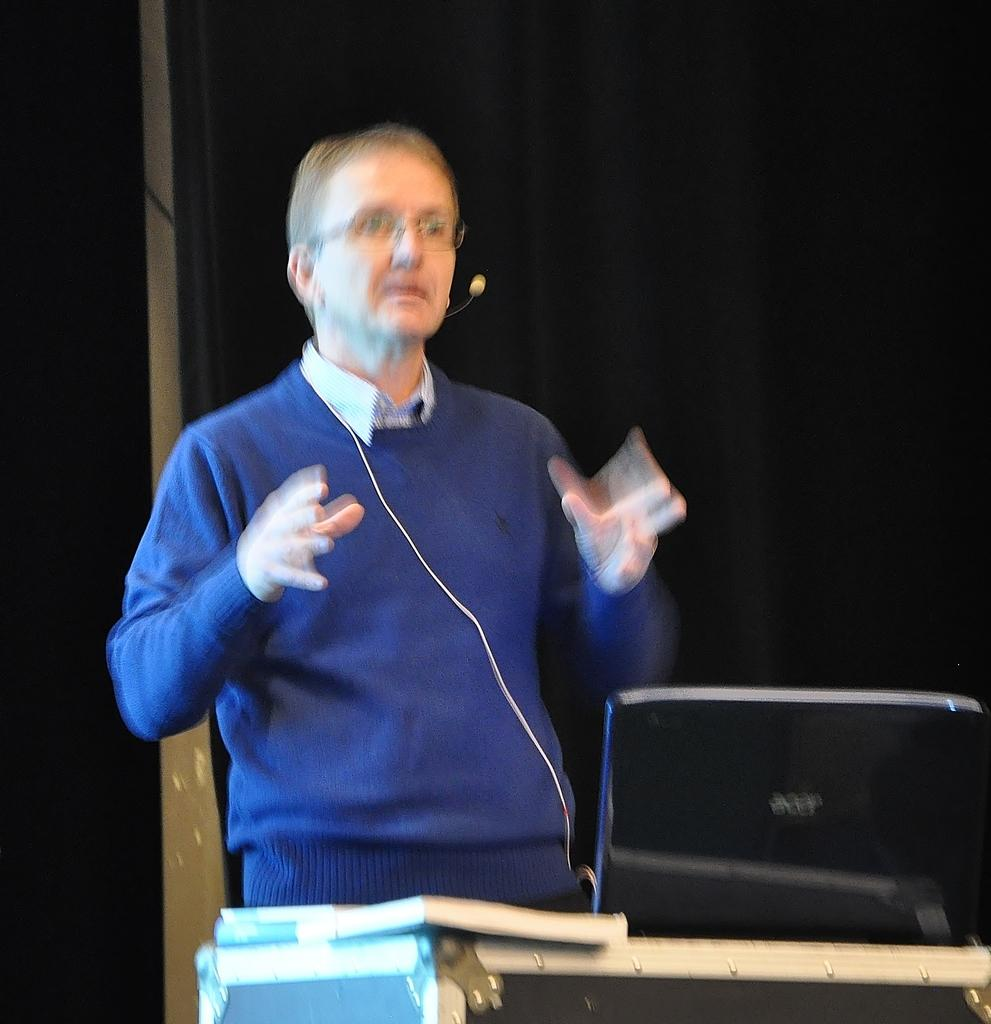What is the main subject of the image? There is a person standing in the image. Where is the person standing in relation to other objects? The person is standing in front of a table. What items can be seen on the table? There are books and a laptop on the table. What is visible behind the person? There is a curtain behind the person. Can you see any squirrels climbing the curtain in the image? No, there are no squirrels visible in the image. Does the person standing in the image appear to be feeling any shame? The image does not provide any information about the person's emotions, so it cannot be determined if they are feeling shame. 